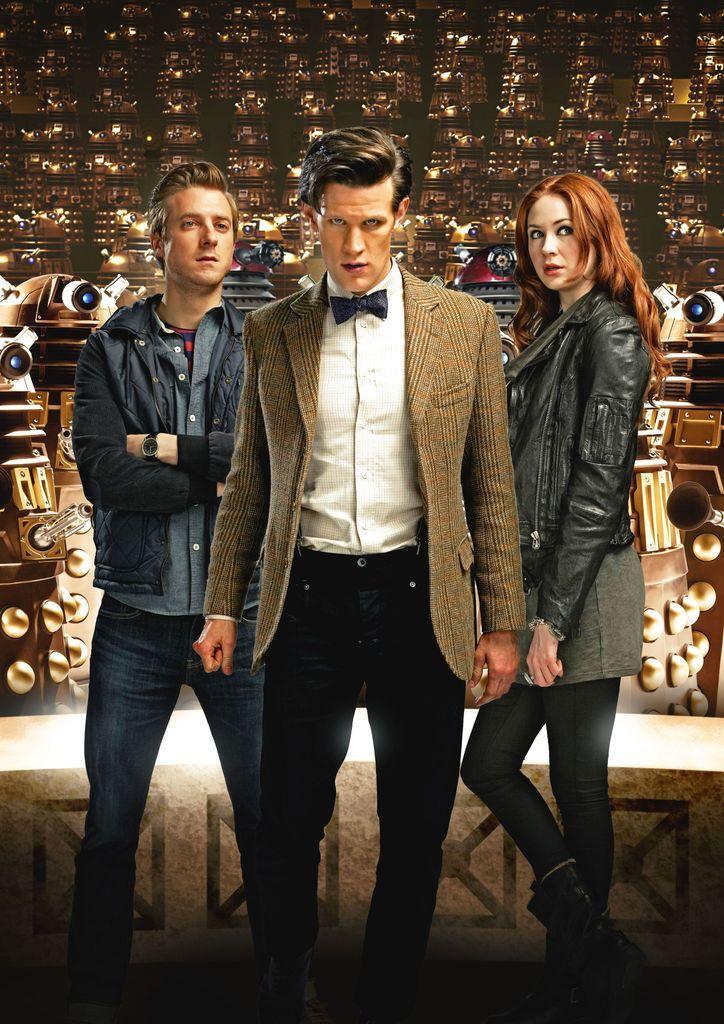In one or two sentences, can you explain what this image depicts? In this picture I can see two men and a woman are standing together. The man in the middle is wearing a suit, shirt and pant. The woman is wearing a jacket. 